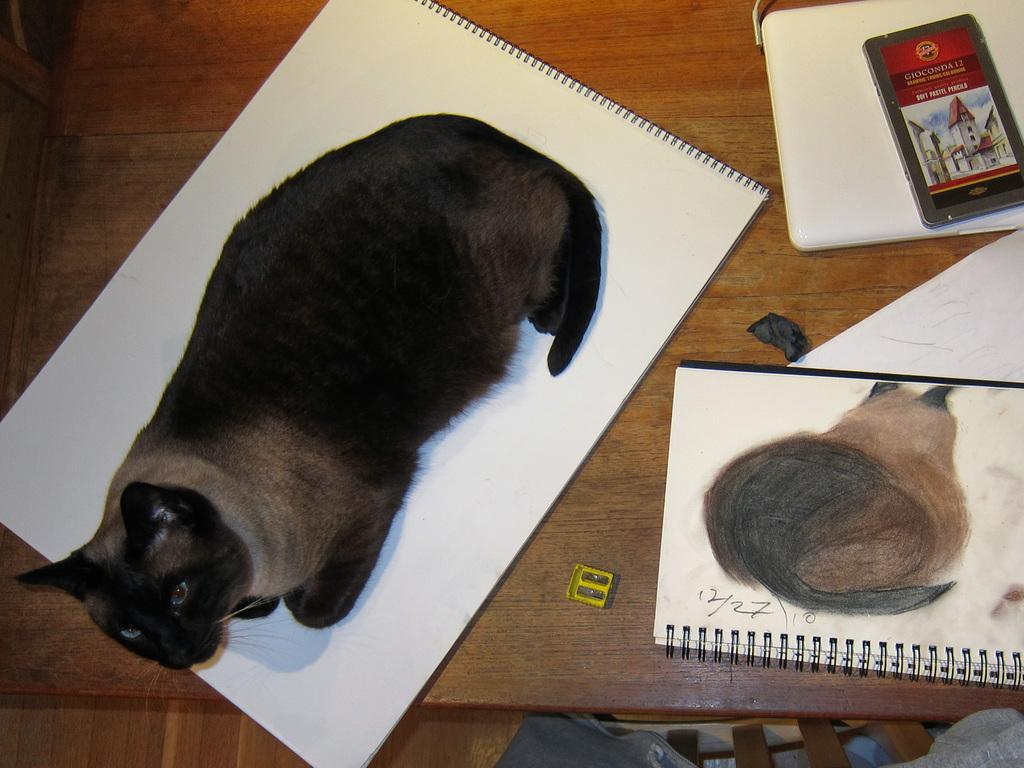What is the main object in the image? There is a cap in the image. What colors are used in the cap? The cap has a black and white color combination. Where is the cap placed in the image? The cap is sitting on a white color page of a book. What is the book placed on? The book is on a table. Are there any other books on the table? Yes, there are other books on the table. What other objects can be seen on the table? There are other objects on the table, but their specific details are not mentioned in the provided facts. What type of breakfast is being served on the table in the image? There is no mention of breakfast or any food items in the image. How many pizzas are visible on the table in the image? There is no mention of pizzas or any food items in the image. 